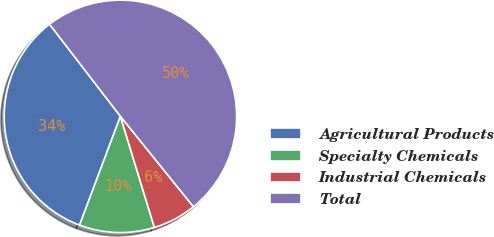Convert chart to OTSL. <chart><loc_0><loc_0><loc_500><loc_500><pie_chart><fcel>Agricultural Products<fcel>Specialty Chemicals<fcel>Industrial Chemicals<fcel>Total<nl><fcel>33.84%<fcel>10.44%<fcel>6.09%<fcel>49.62%<nl></chart> 